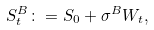<formula> <loc_0><loc_0><loc_500><loc_500>S _ { t } ^ { B } \colon = S _ { 0 } + \sigma ^ { B } W _ { t } ,</formula> 